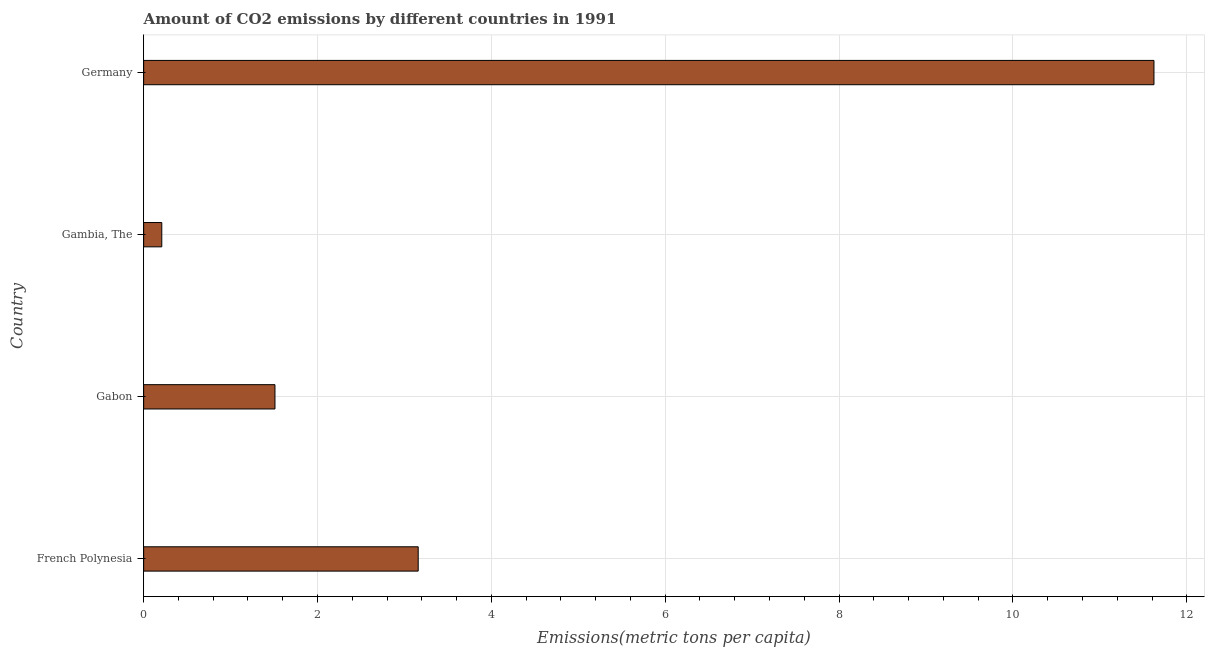Does the graph contain any zero values?
Your answer should be compact. No. What is the title of the graph?
Keep it short and to the point. Amount of CO2 emissions by different countries in 1991. What is the label or title of the X-axis?
Ensure brevity in your answer.  Emissions(metric tons per capita). What is the amount of co2 emissions in Gabon?
Your answer should be very brief. 1.51. Across all countries, what is the maximum amount of co2 emissions?
Keep it short and to the point. 11.62. Across all countries, what is the minimum amount of co2 emissions?
Ensure brevity in your answer.  0.21. In which country was the amount of co2 emissions maximum?
Offer a terse response. Germany. In which country was the amount of co2 emissions minimum?
Make the answer very short. Gambia, The. What is the sum of the amount of co2 emissions?
Your answer should be very brief. 16.5. What is the difference between the amount of co2 emissions in French Polynesia and Gabon?
Make the answer very short. 1.65. What is the average amount of co2 emissions per country?
Give a very brief answer. 4.12. What is the median amount of co2 emissions?
Provide a short and direct response. 2.33. What is the ratio of the amount of co2 emissions in Gabon to that in Germany?
Offer a terse response. 0.13. Is the amount of co2 emissions in Gabon less than that in Gambia, The?
Keep it short and to the point. No. Is the difference between the amount of co2 emissions in French Polynesia and Gambia, The greater than the difference between any two countries?
Your answer should be very brief. No. What is the difference between the highest and the second highest amount of co2 emissions?
Provide a short and direct response. 8.46. Is the sum of the amount of co2 emissions in Gambia, The and Germany greater than the maximum amount of co2 emissions across all countries?
Give a very brief answer. Yes. What is the difference between the highest and the lowest amount of co2 emissions?
Offer a very short reply. 11.41. In how many countries, is the amount of co2 emissions greater than the average amount of co2 emissions taken over all countries?
Provide a succinct answer. 1. How many countries are there in the graph?
Your answer should be compact. 4. What is the difference between two consecutive major ticks on the X-axis?
Your answer should be very brief. 2. Are the values on the major ticks of X-axis written in scientific E-notation?
Keep it short and to the point. No. What is the Emissions(metric tons per capita) of French Polynesia?
Offer a terse response. 3.16. What is the Emissions(metric tons per capita) of Gabon?
Your response must be concise. 1.51. What is the Emissions(metric tons per capita) in Gambia, The?
Provide a succinct answer. 0.21. What is the Emissions(metric tons per capita) of Germany?
Offer a very short reply. 11.62. What is the difference between the Emissions(metric tons per capita) in French Polynesia and Gabon?
Your response must be concise. 1.65. What is the difference between the Emissions(metric tons per capita) in French Polynesia and Gambia, The?
Give a very brief answer. 2.95. What is the difference between the Emissions(metric tons per capita) in French Polynesia and Germany?
Offer a very short reply. -8.46. What is the difference between the Emissions(metric tons per capita) in Gabon and Gambia, The?
Provide a short and direct response. 1.3. What is the difference between the Emissions(metric tons per capita) in Gabon and Germany?
Your response must be concise. -10.11. What is the difference between the Emissions(metric tons per capita) in Gambia, The and Germany?
Make the answer very short. -11.41. What is the ratio of the Emissions(metric tons per capita) in French Polynesia to that in Gabon?
Provide a succinct answer. 2.09. What is the ratio of the Emissions(metric tons per capita) in French Polynesia to that in Gambia, The?
Make the answer very short. 15.14. What is the ratio of the Emissions(metric tons per capita) in French Polynesia to that in Germany?
Keep it short and to the point. 0.27. What is the ratio of the Emissions(metric tons per capita) in Gabon to that in Gambia, The?
Provide a succinct answer. 7.24. What is the ratio of the Emissions(metric tons per capita) in Gabon to that in Germany?
Your response must be concise. 0.13. What is the ratio of the Emissions(metric tons per capita) in Gambia, The to that in Germany?
Your answer should be compact. 0.02. 